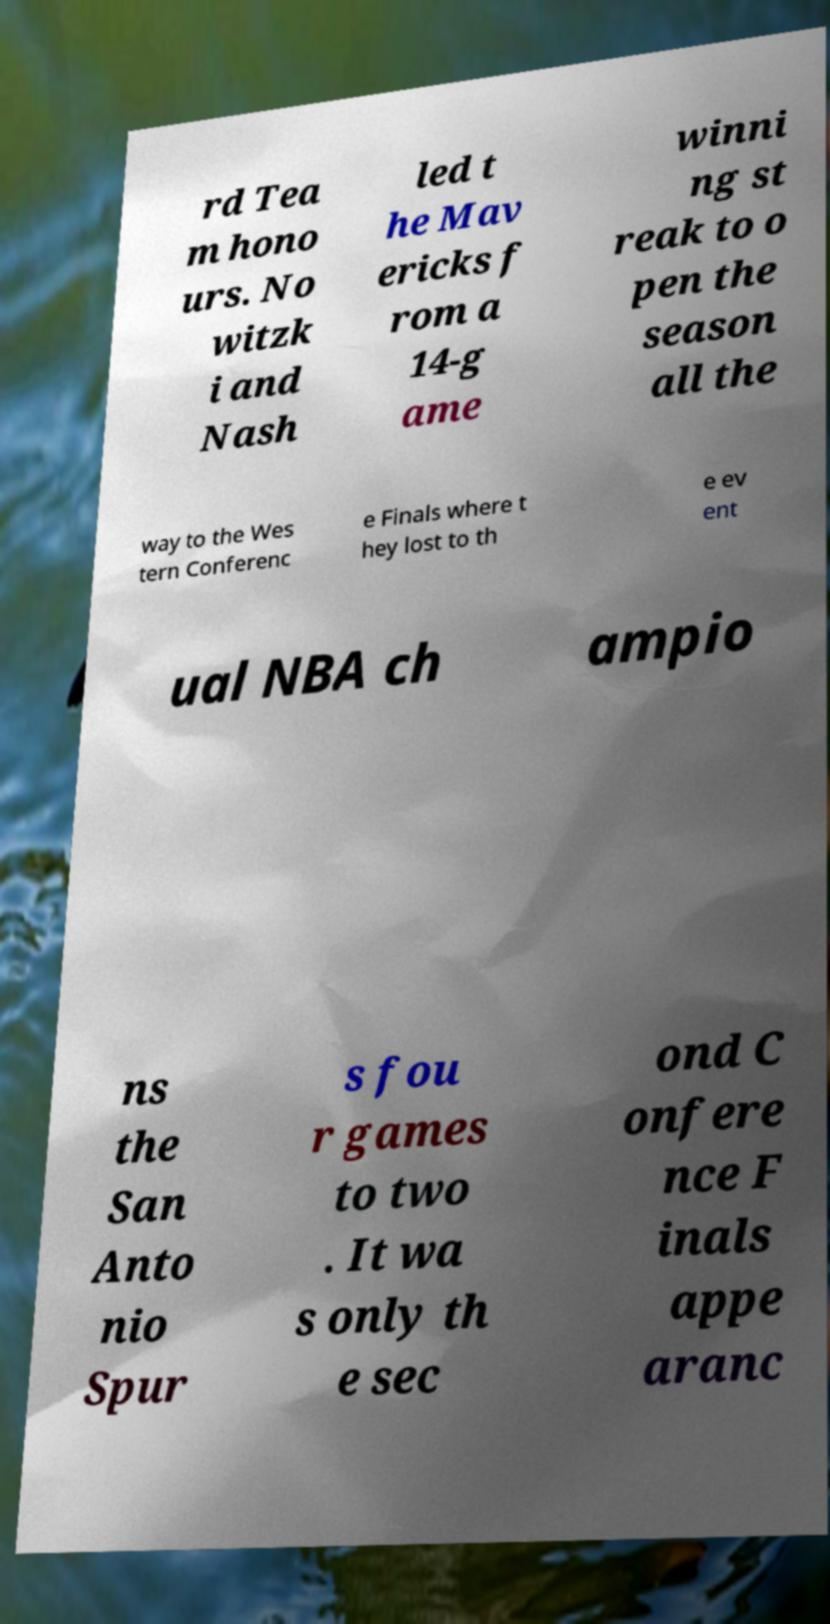Please read and relay the text visible in this image. What does it say? rd Tea m hono urs. No witzk i and Nash led t he Mav ericks f rom a 14-g ame winni ng st reak to o pen the season all the way to the Wes tern Conferenc e Finals where t hey lost to th e ev ent ual NBA ch ampio ns the San Anto nio Spur s fou r games to two . It wa s only th e sec ond C onfere nce F inals appe aranc 